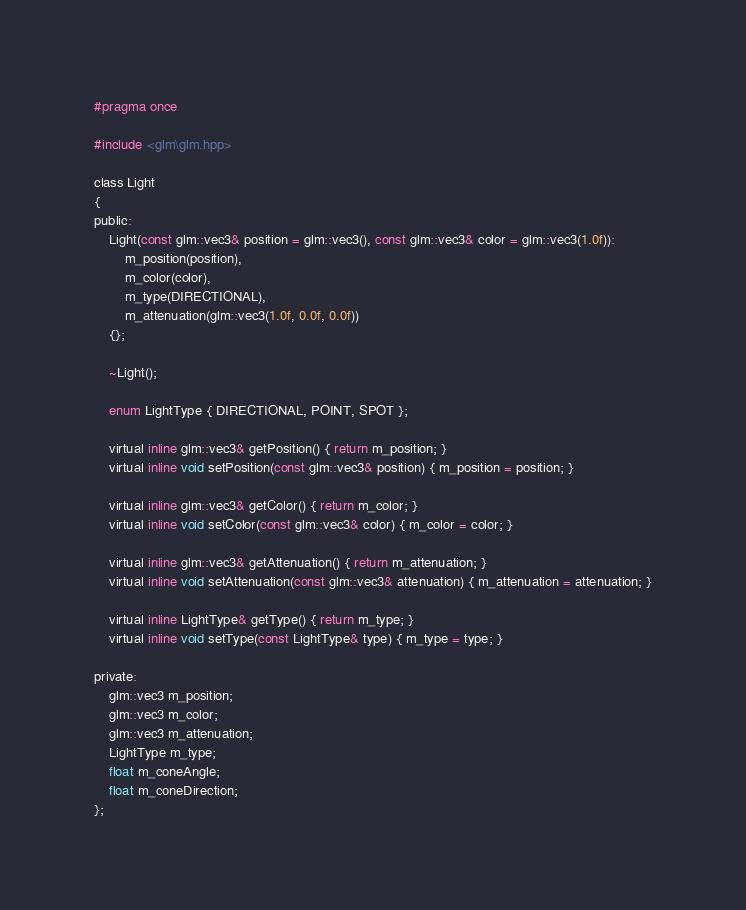<code> <loc_0><loc_0><loc_500><loc_500><_C_>#pragma once

#include <glm\glm.hpp>

class Light
{
public:
	Light(const glm::vec3& position = glm::vec3(), const glm::vec3& color = glm::vec3(1.0f)):
		m_position(position), 
		m_color(color),
		m_type(DIRECTIONAL),
		m_attenuation(glm::vec3(1.0f, 0.0f, 0.0f))
	{};

	~Light();

	enum LightType { DIRECTIONAL, POINT, SPOT };

	virtual inline glm::vec3& getPosition() { return m_position; }
	virtual inline void setPosition(const glm::vec3& position) { m_position = position; }

	virtual inline glm::vec3& getColor() { return m_color; }
	virtual inline void setColor(const glm::vec3& color) { m_color = color; }

	virtual inline glm::vec3& getAttenuation() { return m_attenuation; }
	virtual inline void setAttenuation(const glm::vec3& attenuation) { m_attenuation = attenuation; }

	virtual inline LightType& getType() { return m_type; }
	virtual inline void setType(const LightType& type) { m_type = type; }

private:
	glm::vec3 m_position;
	glm::vec3 m_color;
	glm::vec3 m_attenuation;
	LightType m_type;
	float m_coneAngle;
	float m_coneDirection;
};</code> 